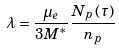Convert formula to latex. <formula><loc_0><loc_0><loc_500><loc_500>\lambda = \frac { \mu _ { e } } { 3 M ^ { \ast } } \frac { N _ { p } \left ( \tau \right ) } { n _ { p } }</formula> 